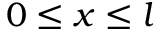Convert formula to latex. <formula><loc_0><loc_0><loc_500><loc_500>0 \leq x \leq l</formula> 